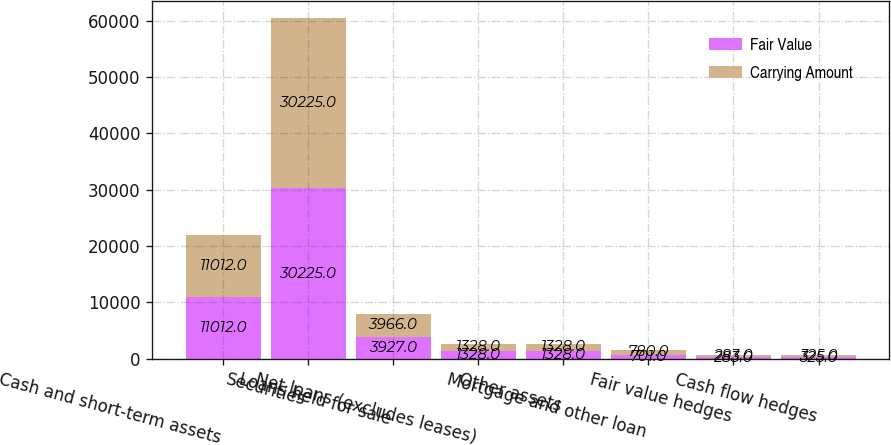Convert chart. <chart><loc_0><loc_0><loc_500><loc_500><stacked_bar_chart><ecel><fcel>Cash and short-term assets<fcel>Securities<fcel>Loans held for sale<fcel>Net loans (excludes leases)<fcel>Other assets<fcel>Mortgage and other loan<fcel>Fair value hedges<fcel>Cash flow hedges<nl><fcel>Fair Value<fcel>11012<fcel>30225<fcel>3927<fcel>1328<fcel>1328<fcel>701<fcel>283<fcel>325<nl><fcel>Carrying Amount<fcel>11012<fcel>30225<fcel>3966<fcel>1328<fcel>1328<fcel>780<fcel>283<fcel>325<nl></chart> 